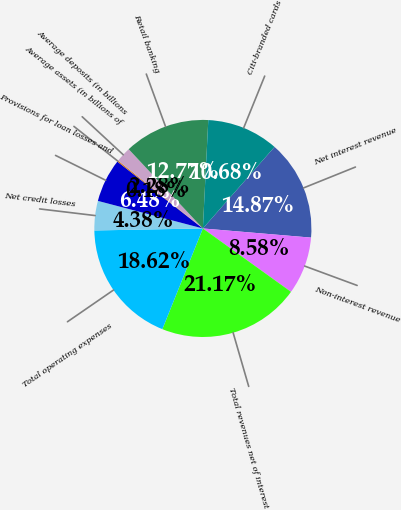<chart> <loc_0><loc_0><loc_500><loc_500><pie_chart><fcel>Net interest revenue<fcel>Non-interest revenue<fcel>Total revenues net of interest<fcel>Total operating expenses<fcel>Net credit losses<fcel>Provisions for loan losses and<fcel>Average assets (in billions of<fcel>Average deposits (in billions<fcel>Retail banking<fcel>Citi-branded cards<nl><fcel>14.87%<fcel>8.58%<fcel>21.17%<fcel>18.62%<fcel>4.38%<fcel>6.48%<fcel>0.18%<fcel>2.28%<fcel>12.77%<fcel>10.68%<nl></chart> 